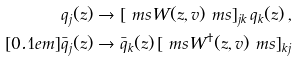<formula> <loc_0><loc_0><loc_500><loc_500>q _ { j } ( z ) & \to [ \ m s W ( z , v ) \ m s ] _ { j k } \, q _ { k } ( z ) \, , \\ [ 0 . 1 e m ] \bar { q } _ { j } ( z ) & \to \bar { q } _ { k } ( z ) \, [ \ m s W ^ { \dagger } ( z , v ) \ m s ] _ { k j }</formula> 